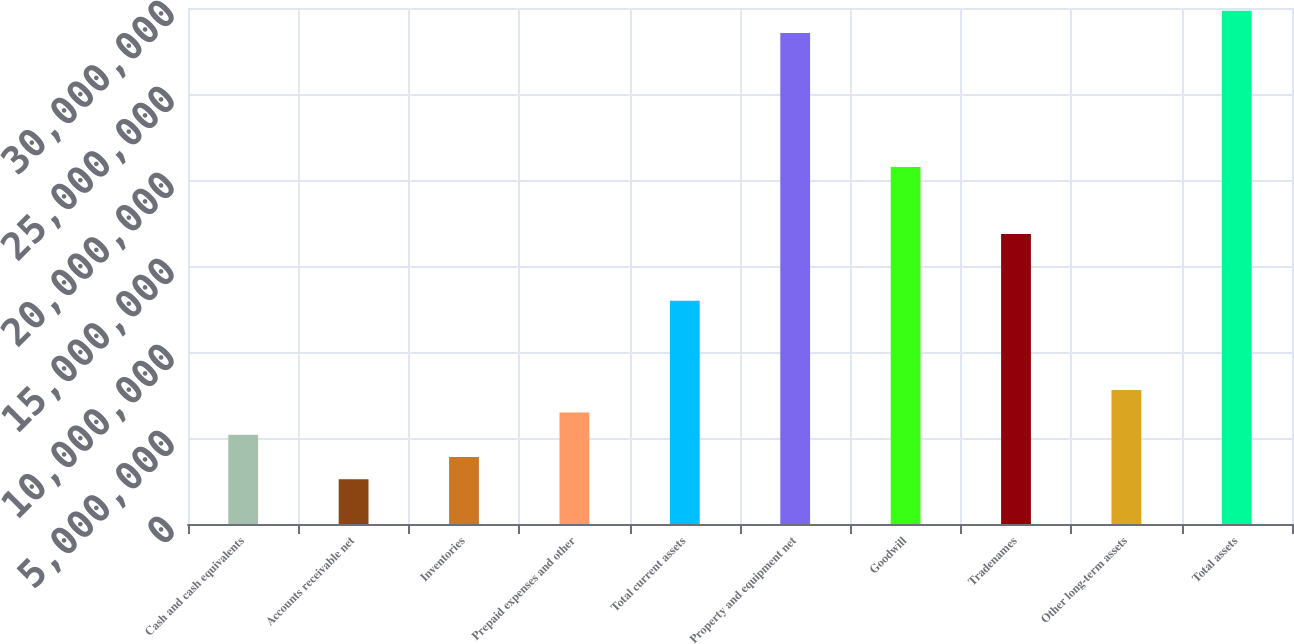<chart> <loc_0><loc_0><loc_500><loc_500><bar_chart><fcel>Cash and cash equivalents<fcel>Accounts receivable net<fcel>Inventories<fcel>Prepaid expenses and other<fcel>Total current assets<fcel>Property and equipment net<fcel>Goodwill<fcel>Tradenames<fcel>Other long-term assets<fcel>Total assets<nl><fcel>5.1897e+06<fcel>2.59497e+06<fcel>3.89234e+06<fcel>6.48707e+06<fcel>1.29739e+07<fcel>2.85423e+07<fcel>2.07581e+07<fcel>1.6866e+07<fcel>7.78444e+06<fcel>2.98397e+07<nl></chart> 